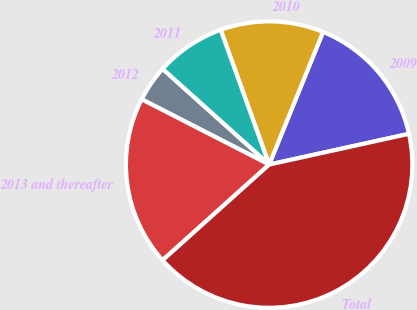Convert chart. <chart><loc_0><loc_0><loc_500><loc_500><pie_chart><fcel>2009<fcel>2010<fcel>2011<fcel>2012<fcel>2013 and thereafter<fcel>Total<nl><fcel>15.41%<fcel>11.64%<fcel>7.87%<fcel>4.1%<fcel>19.18%<fcel>41.8%<nl></chart> 